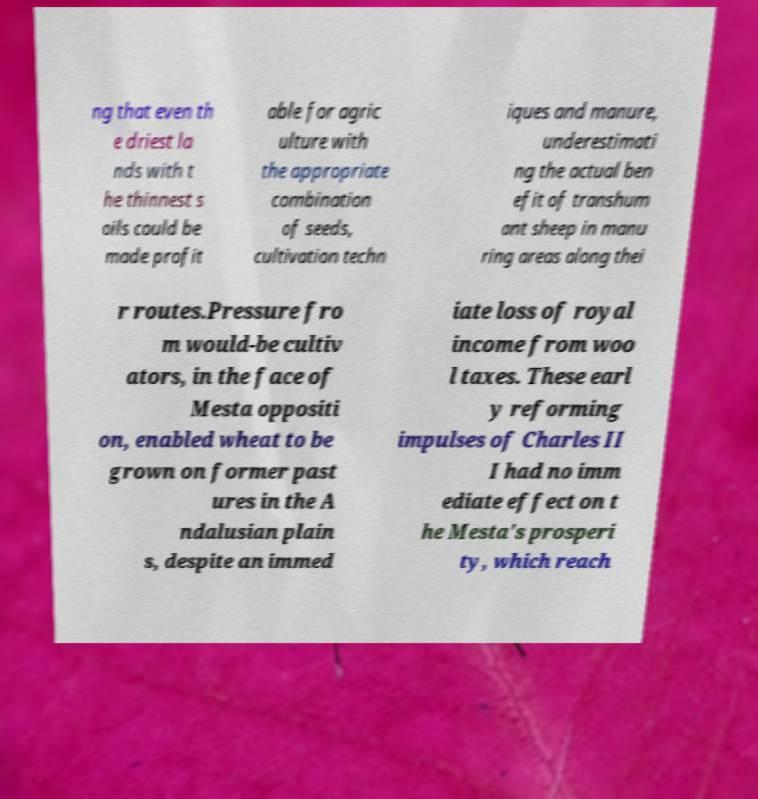Could you extract and type out the text from this image? ng that even th e driest la nds with t he thinnest s oils could be made profit able for agric ulture with the appropriate combination of seeds, cultivation techn iques and manure, underestimati ng the actual ben efit of transhum ant sheep in manu ring areas along thei r routes.Pressure fro m would-be cultiv ators, in the face of Mesta oppositi on, enabled wheat to be grown on former past ures in the A ndalusian plain s, despite an immed iate loss of royal income from woo l taxes. These earl y reforming impulses of Charles II I had no imm ediate effect on t he Mesta's prosperi ty, which reach 